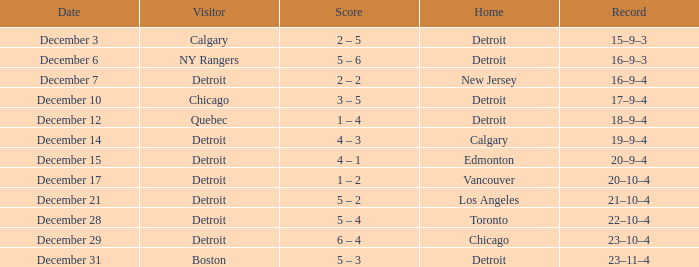Who is the visitor on the date december 31? Boston. 